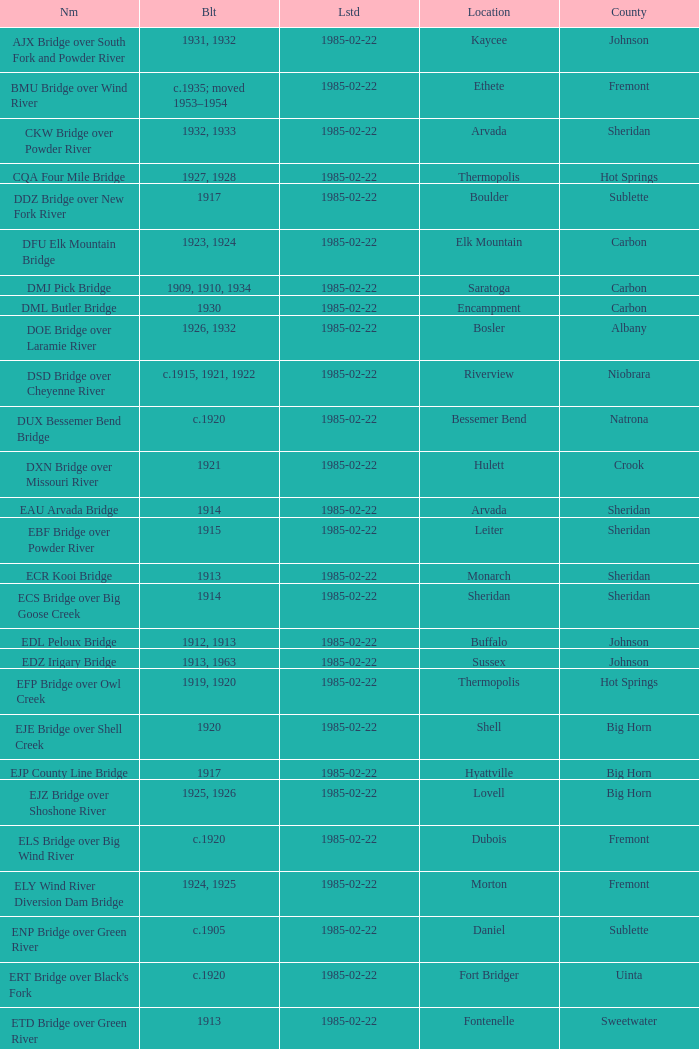Write the full table. {'header': ['Nm', 'Blt', 'Lstd', 'Location', 'County'], 'rows': [['AJX Bridge over South Fork and Powder River', '1931, 1932', '1985-02-22', 'Kaycee', 'Johnson'], ['BMU Bridge over Wind River', 'c.1935; moved 1953–1954', '1985-02-22', 'Ethete', 'Fremont'], ['CKW Bridge over Powder River', '1932, 1933', '1985-02-22', 'Arvada', 'Sheridan'], ['CQA Four Mile Bridge', '1927, 1928', '1985-02-22', 'Thermopolis', 'Hot Springs'], ['DDZ Bridge over New Fork River', '1917', '1985-02-22', 'Boulder', 'Sublette'], ['DFU Elk Mountain Bridge', '1923, 1924', '1985-02-22', 'Elk Mountain', 'Carbon'], ['DMJ Pick Bridge', '1909, 1910, 1934', '1985-02-22', 'Saratoga', 'Carbon'], ['DML Butler Bridge', '1930', '1985-02-22', 'Encampment', 'Carbon'], ['DOE Bridge over Laramie River', '1926, 1932', '1985-02-22', 'Bosler', 'Albany'], ['DSD Bridge over Cheyenne River', 'c.1915, 1921, 1922', '1985-02-22', 'Riverview', 'Niobrara'], ['DUX Bessemer Bend Bridge', 'c.1920', '1985-02-22', 'Bessemer Bend', 'Natrona'], ['DXN Bridge over Missouri River', '1921', '1985-02-22', 'Hulett', 'Crook'], ['EAU Arvada Bridge', '1914', '1985-02-22', 'Arvada', 'Sheridan'], ['EBF Bridge over Powder River', '1915', '1985-02-22', 'Leiter', 'Sheridan'], ['ECR Kooi Bridge', '1913', '1985-02-22', 'Monarch', 'Sheridan'], ['ECS Bridge over Big Goose Creek', '1914', '1985-02-22', 'Sheridan', 'Sheridan'], ['EDL Peloux Bridge', '1912, 1913', '1985-02-22', 'Buffalo', 'Johnson'], ['EDZ Irigary Bridge', '1913, 1963', '1985-02-22', 'Sussex', 'Johnson'], ['EFP Bridge over Owl Creek', '1919, 1920', '1985-02-22', 'Thermopolis', 'Hot Springs'], ['EJE Bridge over Shell Creek', '1920', '1985-02-22', 'Shell', 'Big Horn'], ['EJP County Line Bridge', '1917', '1985-02-22', 'Hyattville', 'Big Horn'], ['EJZ Bridge over Shoshone River', '1925, 1926', '1985-02-22', 'Lovell', 'Big Horn'], ['ELS Bridge over Big Wind River', 'c.1920', '1985-02-22', 'Dubois', 'Fremont'], ['ELY Wind River Diversion Dam Bridge', '1924, 1925', '1985-02-22', 'Morton', 'Fremont'], ['ENP Bridge over Green River', 'c.1905', '1985-02-22', 'Daniel', 'Sublette'], ["ERT Bridge over Black's Fork", 'c.1920', '1985-02-22', 'Fort Bridger', 'Uinta'], ['ETD Bridge over Green River', '1913', '1985-02-22', 'Fontenelle', 'Sweetwater'], ['ETR Big Island Bridge', '1909, 1910', '1985-02-22', 'Green River', 'Sweetwater'], ['EWZ Bridge over East Channel of Laramie River', '1913, 1914', '1985-02-22', 'Wheatland', 'Platte'], ['Hayden Arch Bridge', '1924, 1925', '1985-02-22', 'Cody', 'Park'], ['Rairden Bridge', '1916', '1985-02-22', 'Manderson', 'Big Horn']]} What is the listed for the bridge at Daniel in Sublette county? 1985-02-22. 